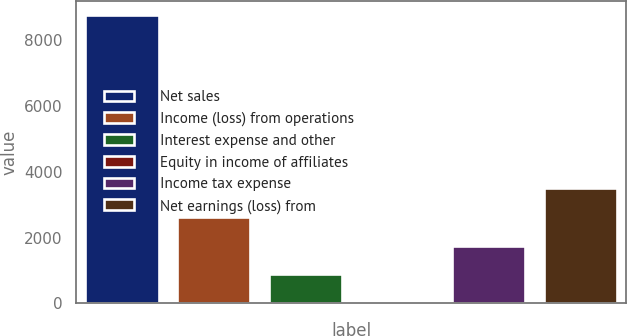<chart> <loc_0><loc_0><loc_500><loc_500><bar_chart><fcel>Net sales<fcel>Income (loss) from operations<fcel>Interest expense and other<fcel>Equity in income of affiliates<fcel>Income tax expense<fcel>Net earnings (loss) from<nl><fcel>8777<fcel>2633.8<fcel>878.6<fcel>1<fcel>1756.2<fcel>3511.4<nl></chart> 